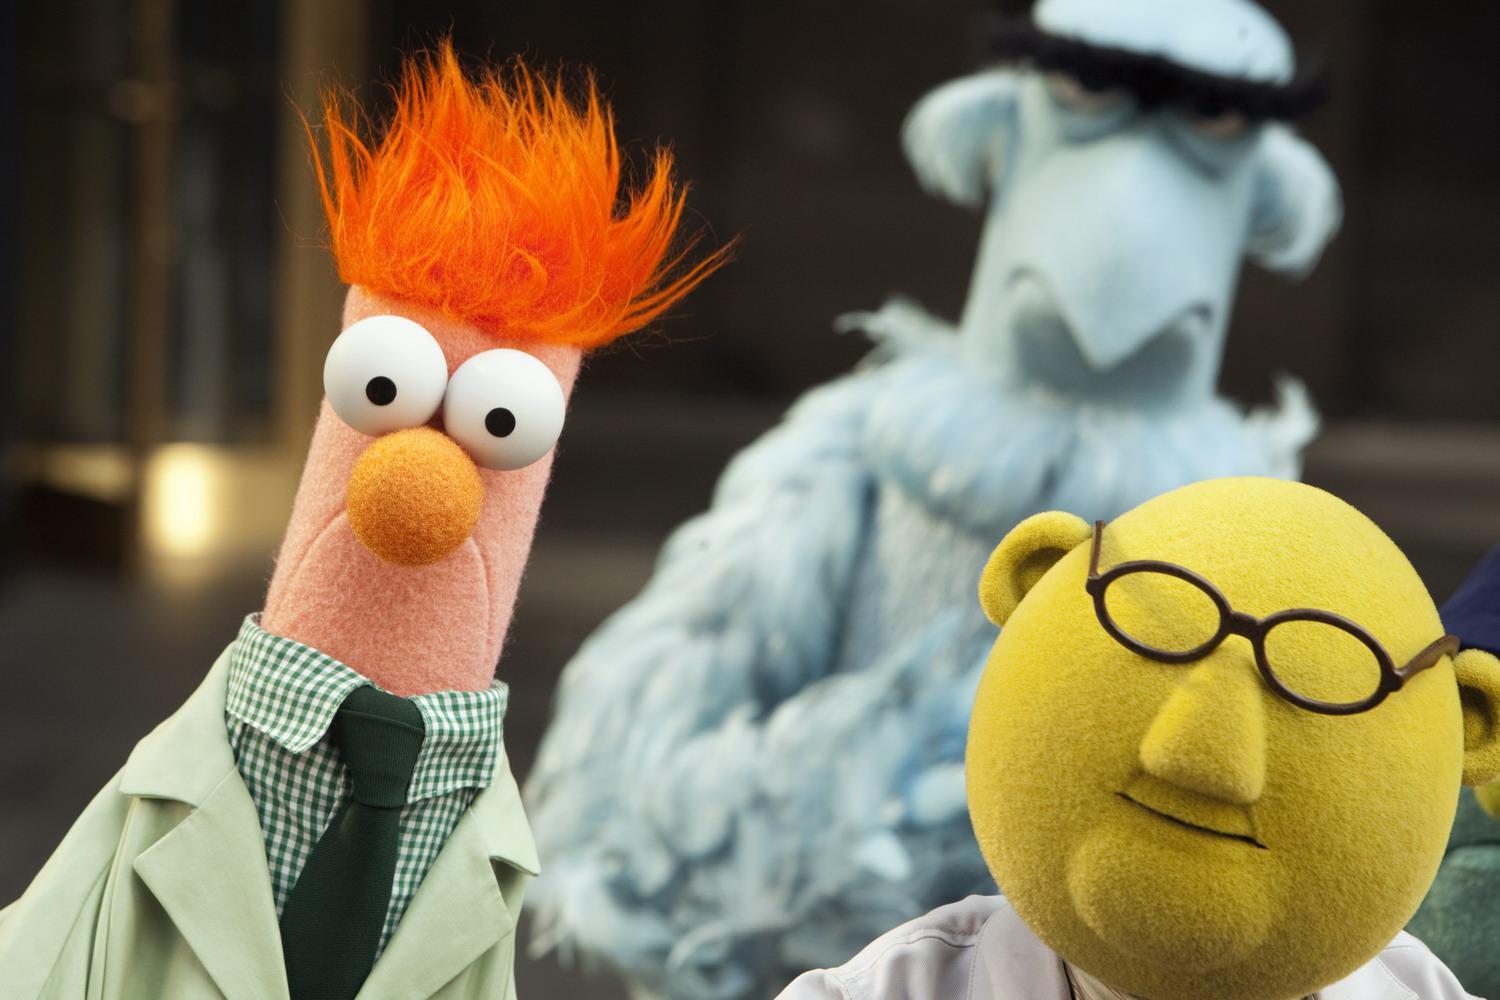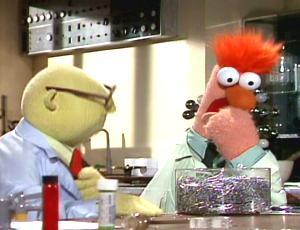The first image is the image on the left, the second image is the image on the right. For the images displayed, is the sentence "Each image has the same two muppets without any other muppets." factually correct? Answer yes or no. No. 